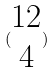Convert formula to latex. <formula><loc_0><loc_0><loc_500><loc_500>( \begin{matrix} 1 2 \\ 4 \end{matrix} )</formula> 